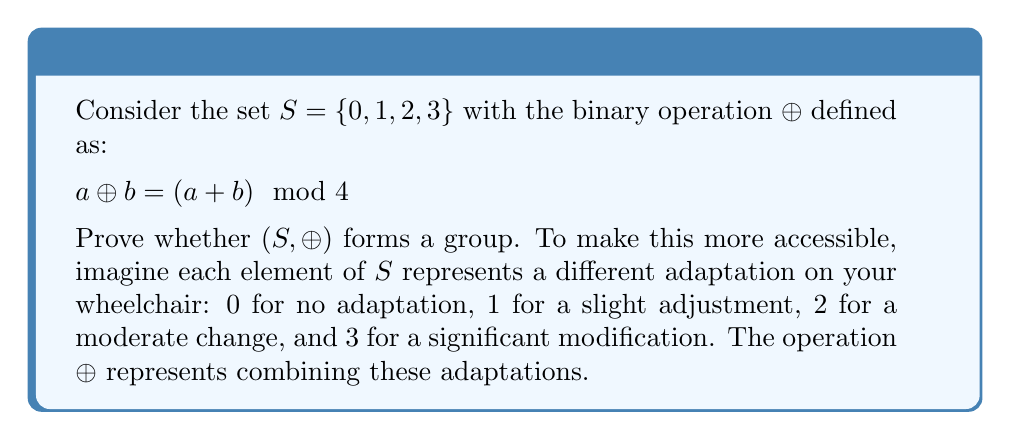Give your solution to this math problem. To prove that $(S, \oplus)$ forms a group, we need to check four properties:

1. Closure: For all $a, b \in S$, $a \oplus b \in S$
2. Associativity: For all $a, b, c \in S$, $(a \oplus b) \oplus c = a \oplus (b \oplus c)$
3. Identity element: There exists an $e \in S$ such that $a \oplus e = e \oplus a = a$ for all $a \in S$
4. Inverse element: For each $a \in S$, there exists a $b \in S$ such that $a \oplus b = b \oplus a = e$

Let's check each property:

1. Closure:
   For any $a, b \in S$, $a \oplus b = (a + b) \mod 4$ will always result in 0, 1, 2, or 3, which are all in $S$. Thus, closure is satisfied.

2. Associativity:
   For any $a, b, c \in S$:
   $$(a \oplus b) \oplus c = ((a + b) \mod 4 + c) \mod 4 = (a + b + c) \mod 4$$
   $$a \oplus (b \oplus c) = (a + (b + c) \mod 4) \mod 4 = (a + b + c) \mod 4$$
   Thus, associativity holds.

3. Identity element:
   The identity element is 0, because for any $a \in S$:
   $$a \oplus 0 = (a + 0) \mod 4 = a$$
   $$0 \oplus a = (0 + a) \mod 4 = a$$

4. Inverse element:
   For each element in $S$, we can find its inverse:
   - 0: $0 \oplus 0 = 0$
   - 1: $1 \oplus 3 = 0$
   - 2: $2 \oplus 2 = 0$
   - 3: $3 \oplus 1 = 0$

Since all four properties are satisfied, $(S, \oplus)$ forms a group.
Answer: Yes, $(S, \oplus)$ forms a group because it satisfies all four group properties: closure, associativity, identity element, and inverse element. 